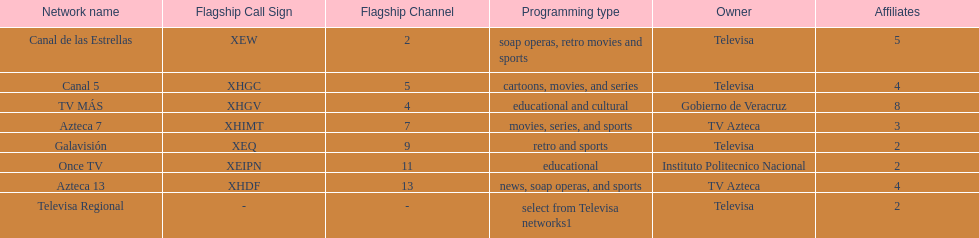Which is the only station with 8 affiliates? TV MÁS. 